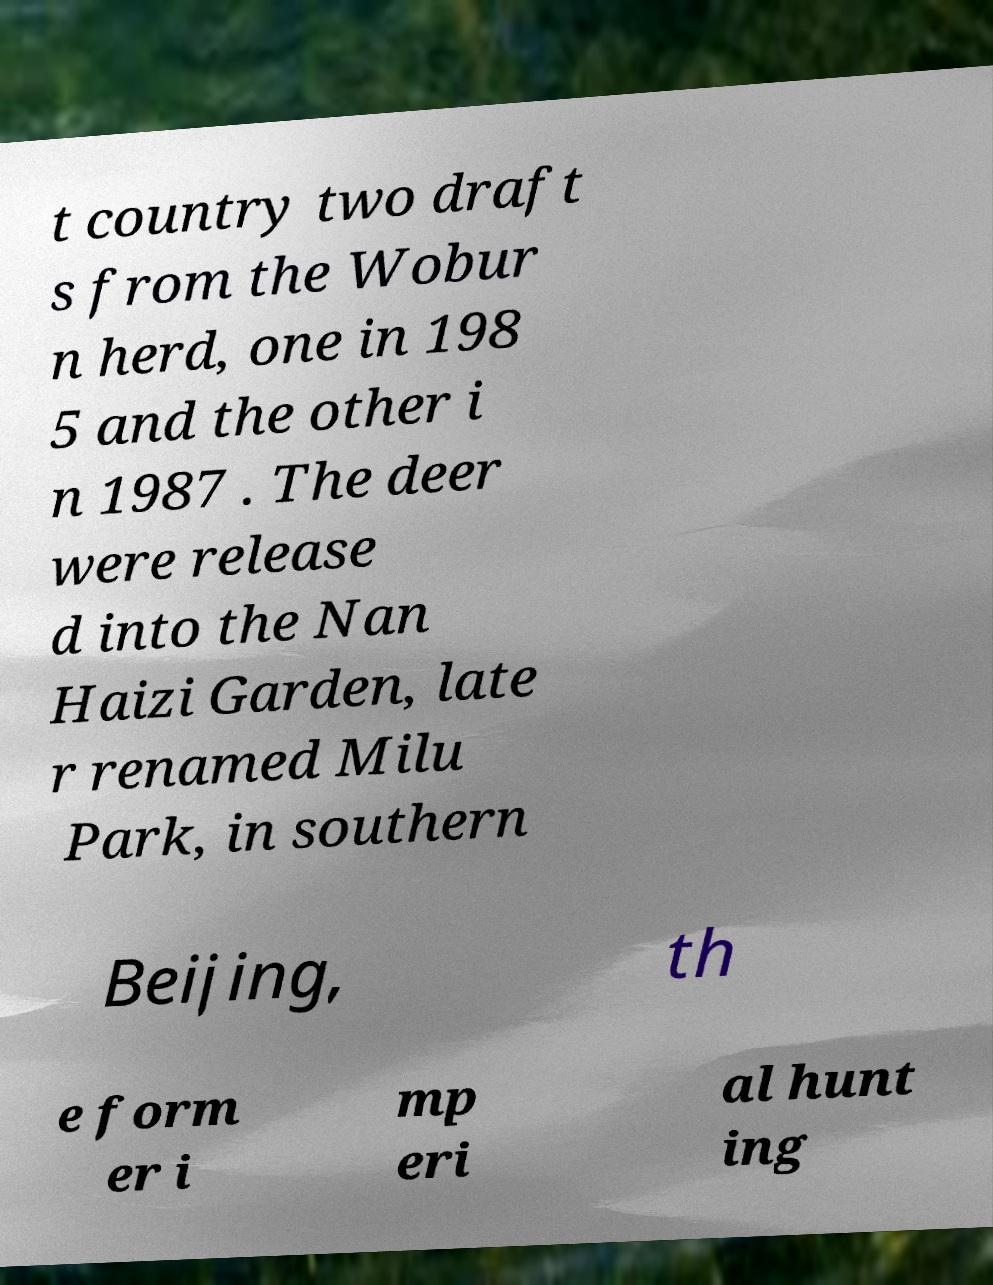Can you read and provide the text displayed in the image?This photo seems to have some interesting text. Can you extract and type it out for me? t country two draft s from the Wobur n herd, one in 198 5 and the other i n 1987 . The deer were release d into the Nan Haizi Garden, late r renamed Milu Park, in southern Beijing, th e form er i mp eri al hunt ing 